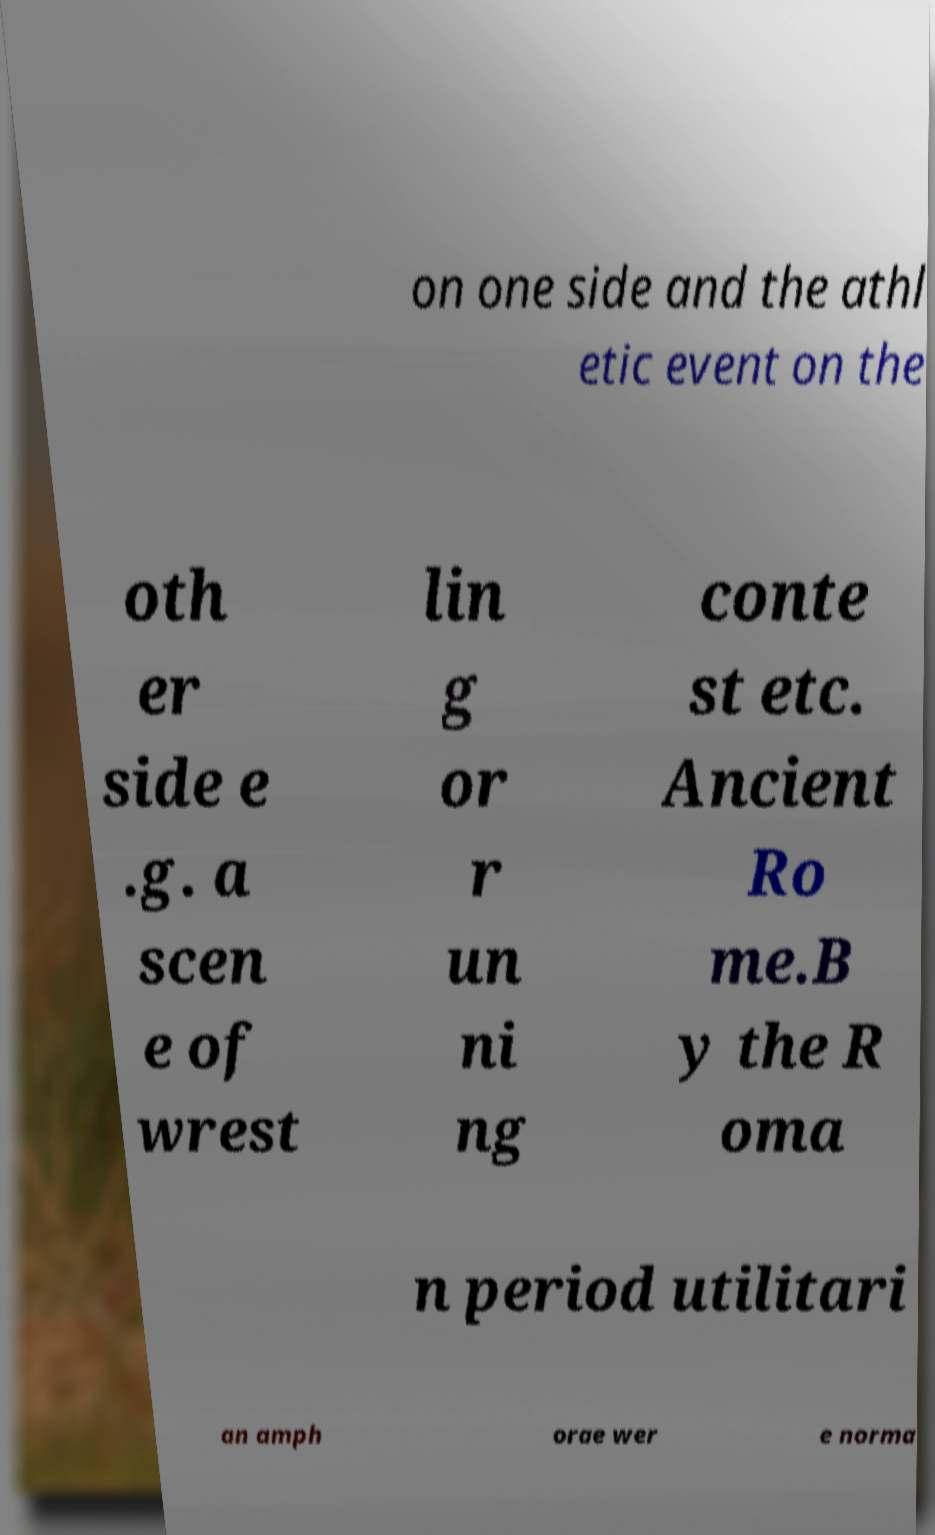Can you read and provide the text displayed in the image?This photo seems to have some interesting text. Can you extract and type it out for me? on one side and the athl etic event on the oth er side e .g. a scen e of wrest lin g or r un ni ng conte st etc. Ancient Ro me.B y the R oma n period utilitari an amph orae wer e norma 